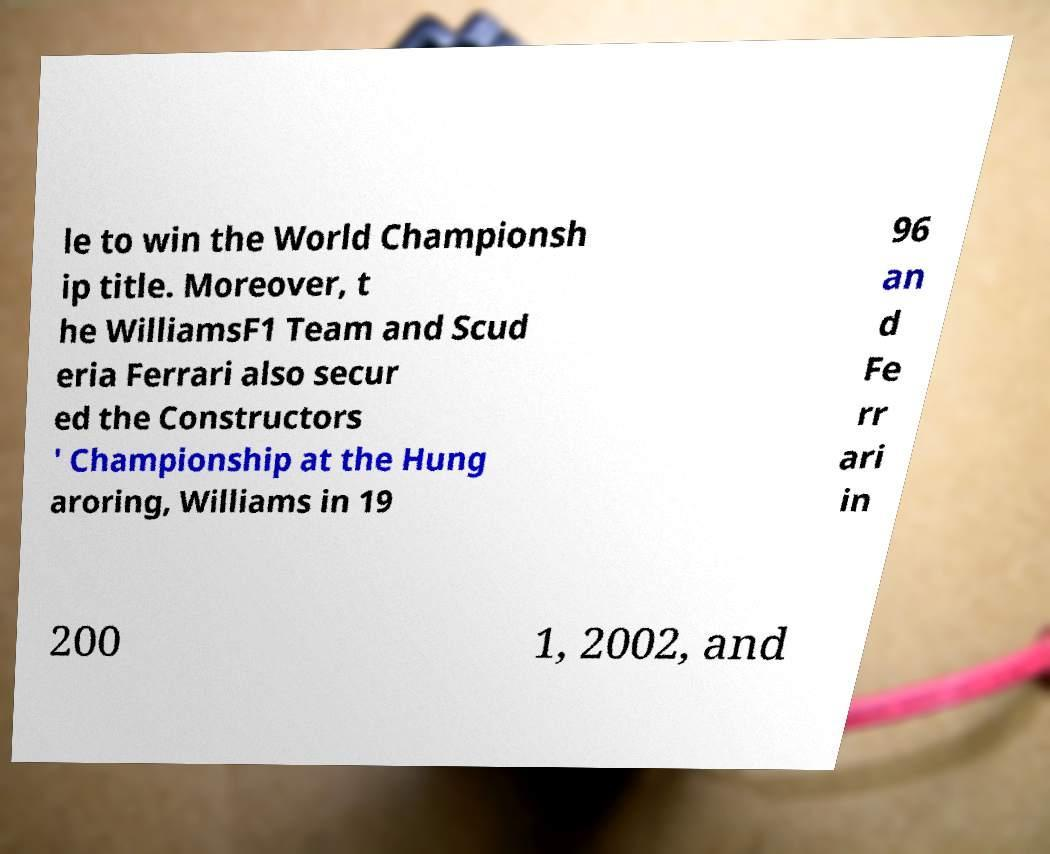Could you assist in decoding the text presented in this image and type it out clearly? le to win the World Championsh ip title. Moreover, t he WilliamsF1 Team and Scud eria Ferrari also secur ed the Constructors ' Championship at the Hung aroring, Williams in 19 96 an d Fe rr ari in 200 1, 2002, and 